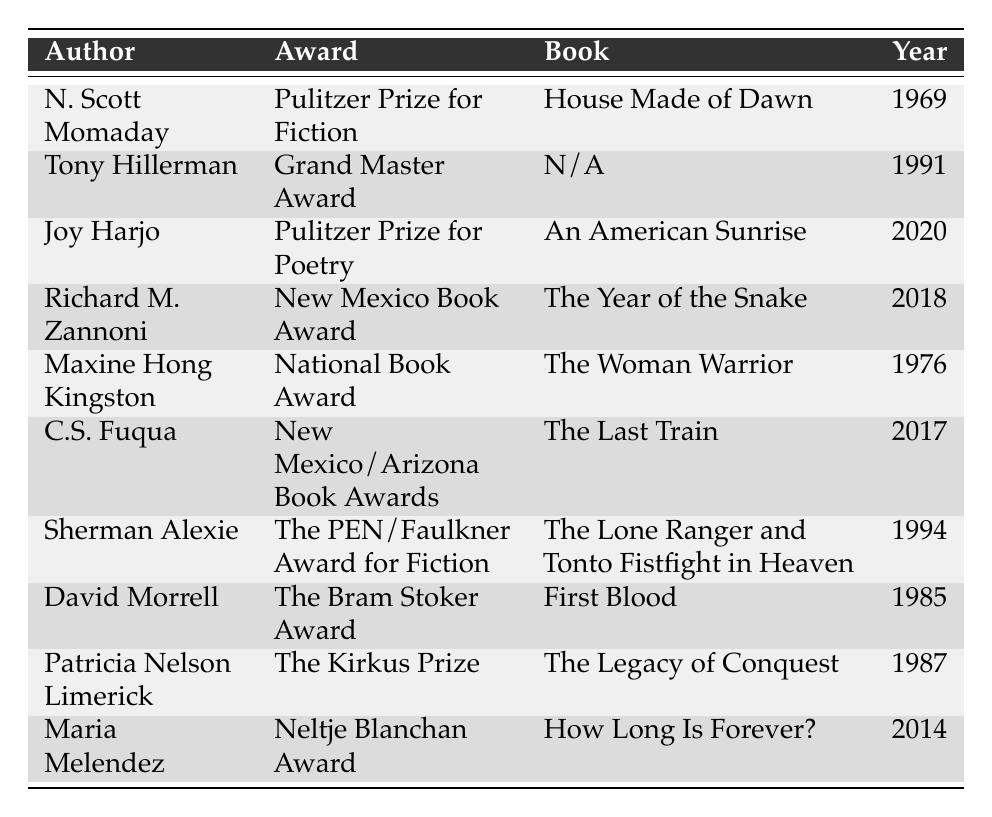What award did N. Scott Momaday win? N. Scott Momaday is listed in the table under the author column, and his corresponding award is the Pulitzer Prize for Fiction.
Answer: Pulitzer Prize for Fiction Which year did Joy Harjo win her award? Joy Harjo is in the table, and her award was won in the year 2020 as indicated in the year column.
Answer: 2020 Is the book "The Woman Warrior" associated with any award? In the table, "The Woman Warrior" is connected to the National Book Award, which is mentioned in the award column related to Maxine Hong Kingston.
Answer: Yes How many authors won awards in the 1980s? From the table, there are three authors who won awards in the 1980s: David Morrell (1985), Patricia Nelson Limerick (1987), and Sherman Alexie (1994), so counting them gives a total of three.
Answer: 3 Which author won the New Mexico Book Award and what was the title of their book? The table lists Richard M. Zannoni as the author who won the New Mexico Book Award for the book "The Year of the Snake."
Answer: Richard M. Zannoni, "The Year of the Snake" List the authors who won a Pulitzer Prize. In the table, the authors who won a Pulitzer Prize are N. Scott Momaday and Joy Harjo.
Answer: N. Scott Momaday, Joy Harjo What is the earliest awarded literary accomplishment in the table? Examining the year column, the earliest award is the Pulitzer Prize for Fiction won by N. Scott Momaday in 1969, making it the earliest literary accomplishment.
Answer: Pulitzer Prize for Fiction, 1969 How many awards did authors from New Mexico win in the 21st century? Since the table shows the years 2014 (Maria Melendez) and 2020 (Joy Harjo) as dates of award wins, there are a total of two authors who won awards in the 21st century.
Answer: 2 Which author has the most recent award according to the table? Joy Harjo's award in 2020 is the most recent year listed in the table, making her the author with the latest recognition.
Answer: Joy Harjo Did any author win an award after 2010? Yes, both Maria Melendez in 2014 and Joy Harjo in 2020 won awards after 2010, as indicated by the years in the table.
Answer: Yes 